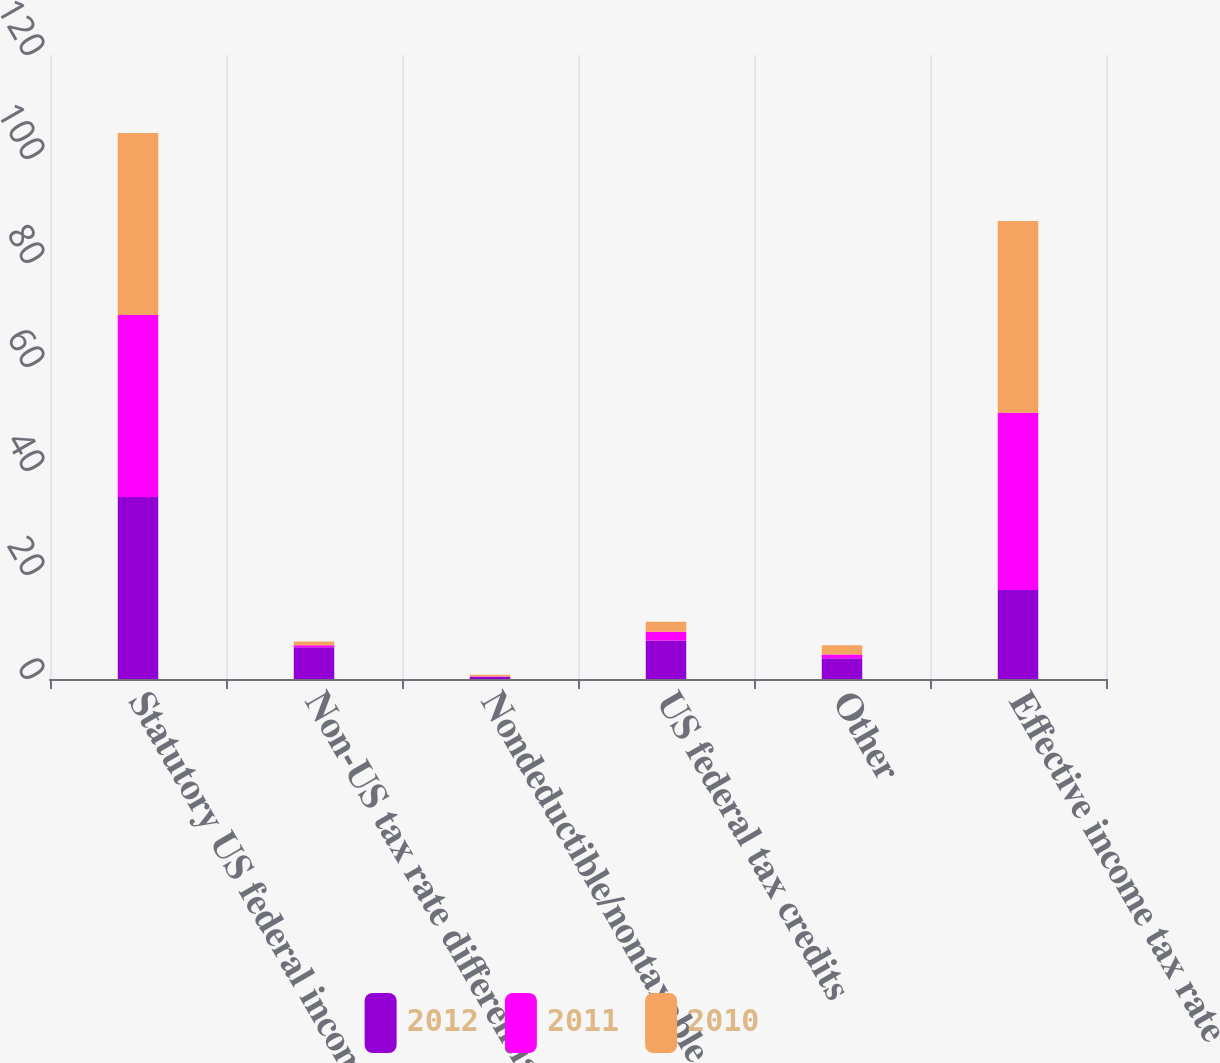<chart> <loc_0><loc_0><loc_500><loc_500><stacked_bar_chart><ecel><fcel>Statutory US federal income<fcel>Non-US tax rate differential<fcel>Nondeductible/nontaxable items<fcel>US federal tax credits<fcel>Other<fcel>Effective income tax rate<nl><fcel>2012<fcel>35<fcel>6.1<fcel>0.4<fcel>7.4<fcel>4<fcel>17.1<nl><fcel>2011<fcel>35<fcel>0.4<fcel>0.1<fcel>1.7<fcel>0.7<fcel>34.1<nl><fcel>2010<fcel>35<fcel>0.7<fcel>0.3<fcel>1.9<fcel>1.8<fcel>36.9<nl></chart> 